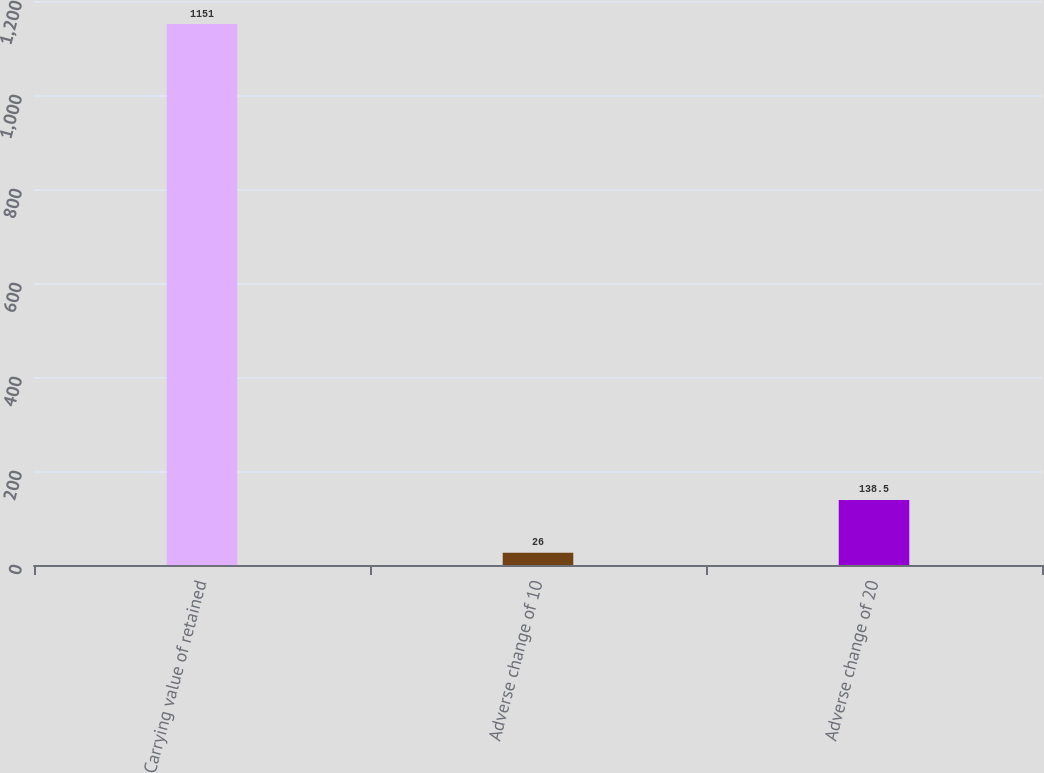<chart> <loc_0><loc_0><loc_500><loc_500><bar_chart><fcel>Carrying value of retained<fcel>Adverse change of 10<fcel>Adverse change of 20<nl><fcel>1151<fcel>26<fcel>138.5<nl></chart> 